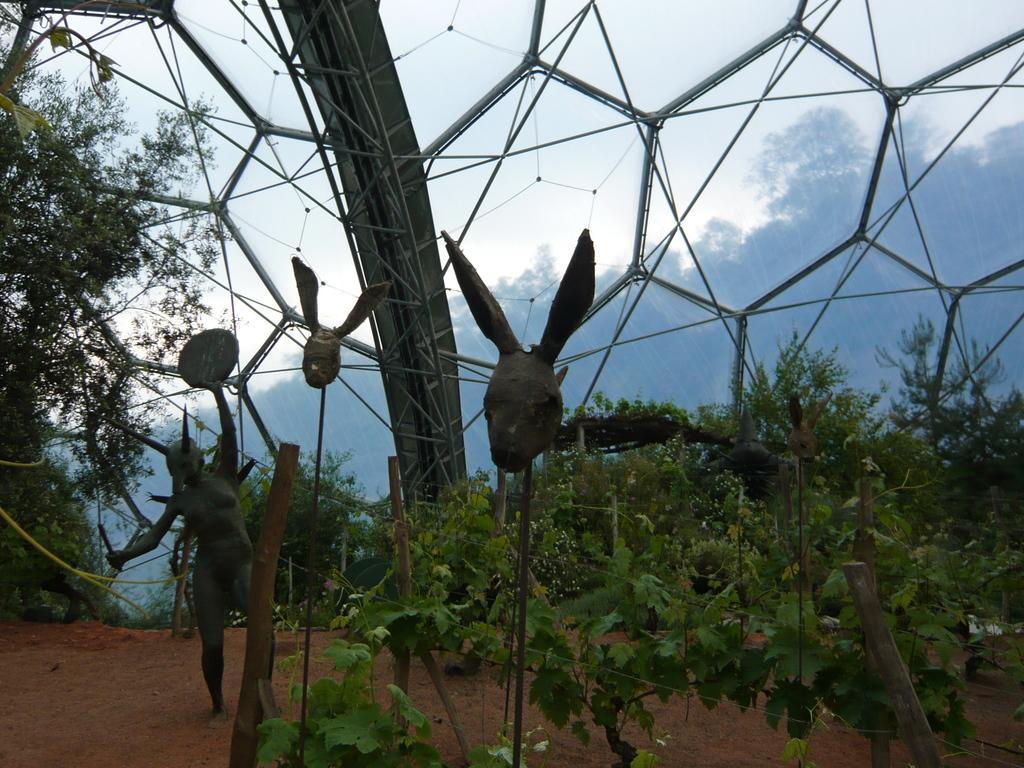Please provide a concise description of this image. In the foreground of this image we can see some statues, group of wooden poles, fence, group of plants. In the background, we can see a group of trees, metal frames and the cloudy sky. 